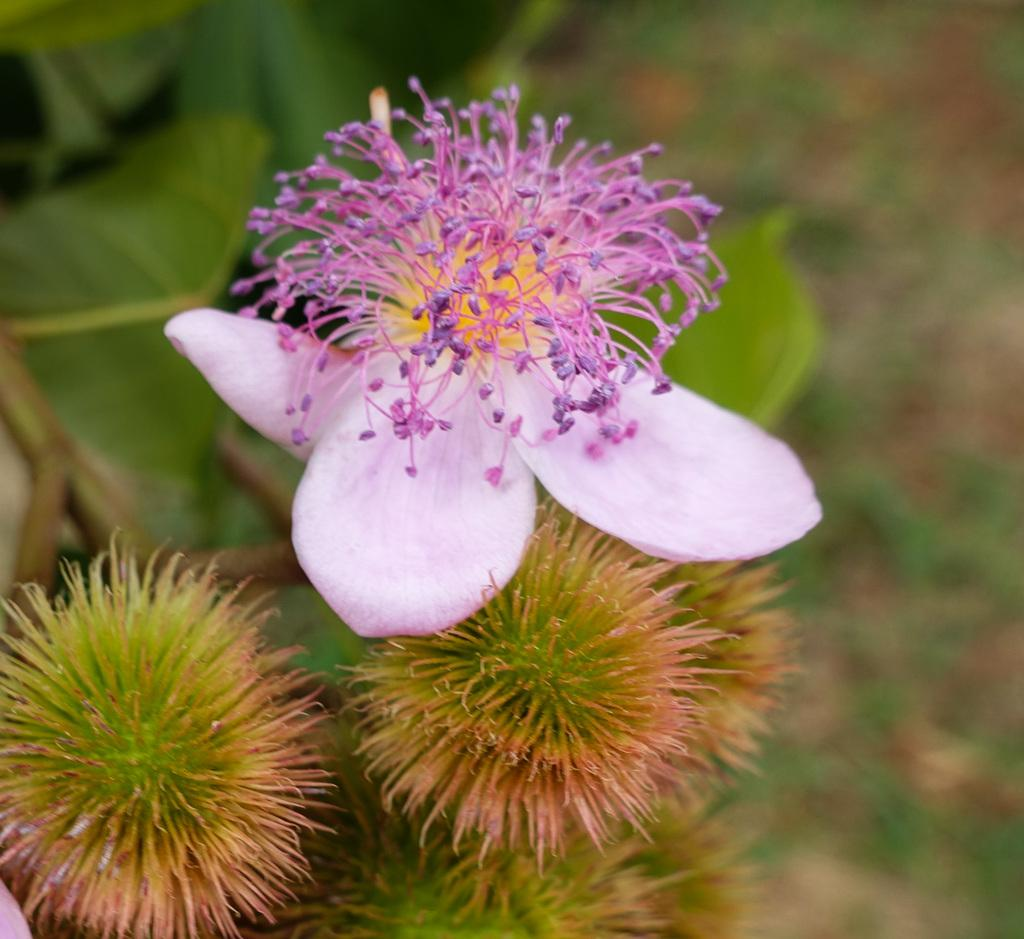What type of plants can be seen in the image? There are flowers and leaves in the image. What can be observed about the background of the image? The background of the image is blurry. What type of oil is being used to clean the curtain in the image? There is no curtain or oil present in the image; it features flowers and leaves with a blurry background. 